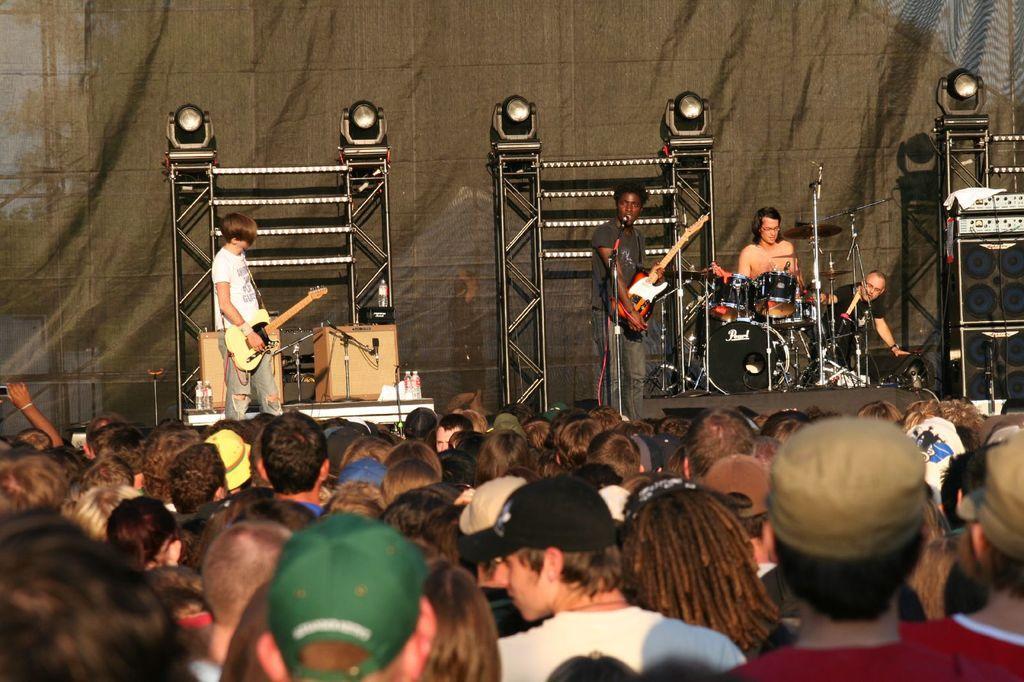Could you give a brief overview of what you see in this image? This is the picture of a concert where we have some people standing on the floor and four people playing musical instruments on the stage. 